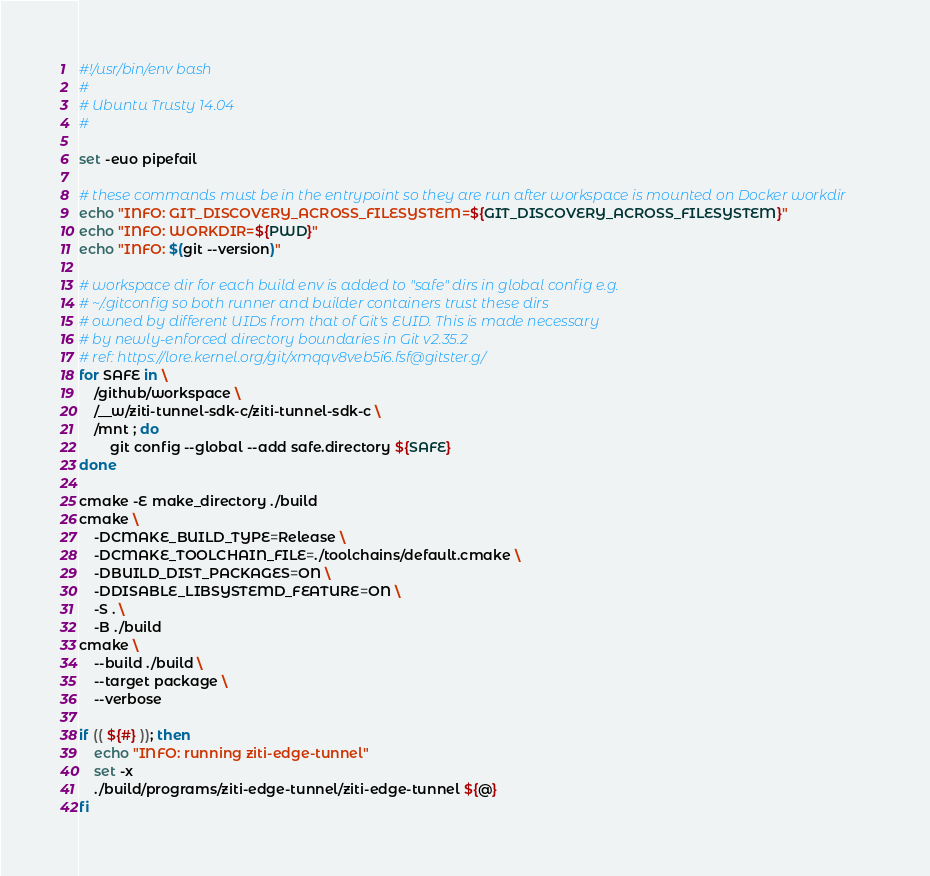<code> <loc_0><loc_0><loc_500><loc_500><_Bash_>#!/usr/bin/env bash
#
# Ubuntu Trusty 14.04
#

set -euo pipefail

# these commands must be in the entrypoint so they are run after workspace is mounted on Docker workdir
echo "INFO: GIT_DISCOVERY_ACROSS_FILESYSTEM=${GIT_DISCOVERY_ACROSS_FILESYSTEM}"
echo "INFO: WORKDIR=${PWD}"
echo "INFO: $(git --version)"

# workspace dir for each build env is added to "safe" dirs in global config e.g.
# ~/.gitconfig so both runner and builder containers trust these dirs
# owned by different UIDs from that of Git's EUID. This is made necessary
# by newly-enforced directory boundaries in Git v2.35.2
# ref: https://lore.kernel.org/git/xmqqv8veb5i6.fsf@gitster.g/
for SAFE in \
    /github/workspace \
    /__w/ziti-tunnel-sdk-c/ziti-tunnel-sdk-c \
    /mnt ; do
        git config --global --add safe.directory ${SAFE}
done

cmake -E make_directory ./build  
cmake \
    -DCMAKE_BUILD_TYPE=Release \
    -DCMAKE_TOOLCHAIN_FILE=./toolchains/default.cmake \
    -DBUILD_DIST_PACKAGES=ON \
    -DDISABLE_LIBSYSTEMD_FEATURE=ON \
    -S . \
    -B ./build 
cmake \
    --build ./build \
    --target package \
    --verbose

if (( ${#} )); then
    echo "INFO: running ziti-edge-tunnel"
    set -x
    ./build/programs/ziti-edge-tunnel/ziti-edge-tunnel ${@}
fi
</code> 